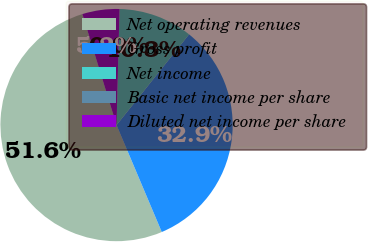Convert chart. <chart><loc_0><loc_0><loc_500><loc_500><pie_chart><fcel>Net operating revenues<fcel>Gross profit<fcel>Net income<fcel>Basic net income per share<fcel>Diluted net income per share<nl><fcel>51.61%<fcel>32.9%<fcel>10.32%<fcel>0.0%<fcel>5.16%<nl></chart> 